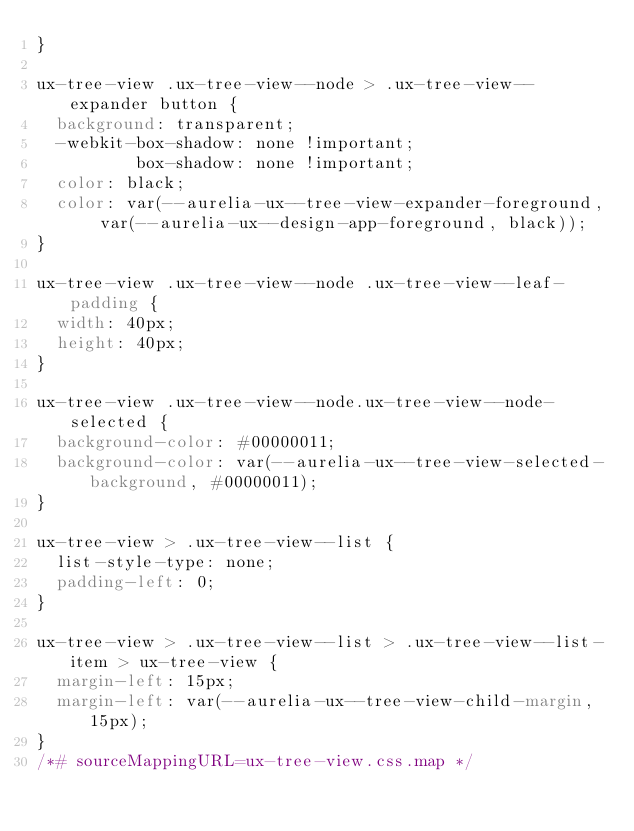<code> <loc_0><loc_0><loc_500><loc_500><_CSS_>}

ux-tree-view .ux-tree-view--node > .ux-tree-view--expander button {
  background: transparent;
  -webkit-box-shadow: none !important;
          box-shadow: none !important;
  color: black;
  color: var(--aurelia-ux--tree-view-expander-foreground, var(--aurelia-ux--design-app-foreground, black));
}

ux-tree-view .ux-tree-view--node .ux-tree-view--leaf-padding {
  width: 40px;
  height: 40px;
}

ux-tree-view .ux-tree-view--node.ux-tree-view--node-selected {
  background-color: #00000011;
  background-color: var(--aurelia-ux--tree-view-selected-background, #00000011);
}

ux-tree-view > .ux-tree-view--list {
  list-style-type: none;
  padding-left: 0;
}

ux-tree-view > .ux-tree-view--list > .ux-tree-view--list-item > ux-tree-view {
  margin-left: 15px;
  margin-left: var(--aurelia-ux--tree-view-child-margin, 15px);
}
/*# sourceMappingURL=ux-tree-view.css.map */</code> 